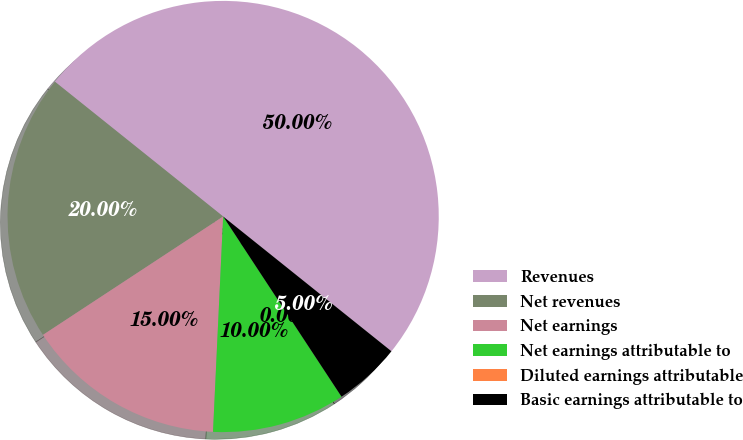Convert chart to OTSL. <chart><loc_0><loc_0><loc_500><loc_500><pie_chart><fcel>Revenues<fcel>Net revenues<fcel>Net earnings<fcel>Net earnings attributable to<fcel>Diluted earnings attributable<fcel>Basic earnings attributable to<nl><fcel>50.0%<fcel>20.0%<fcel>15.0%<fcel>10.0%<fcel>0.0%<fcel>5.0%<nl></chart> 